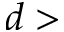<formula> <loc_0><loc_0><loc_500><loc_500>d ></formula> 